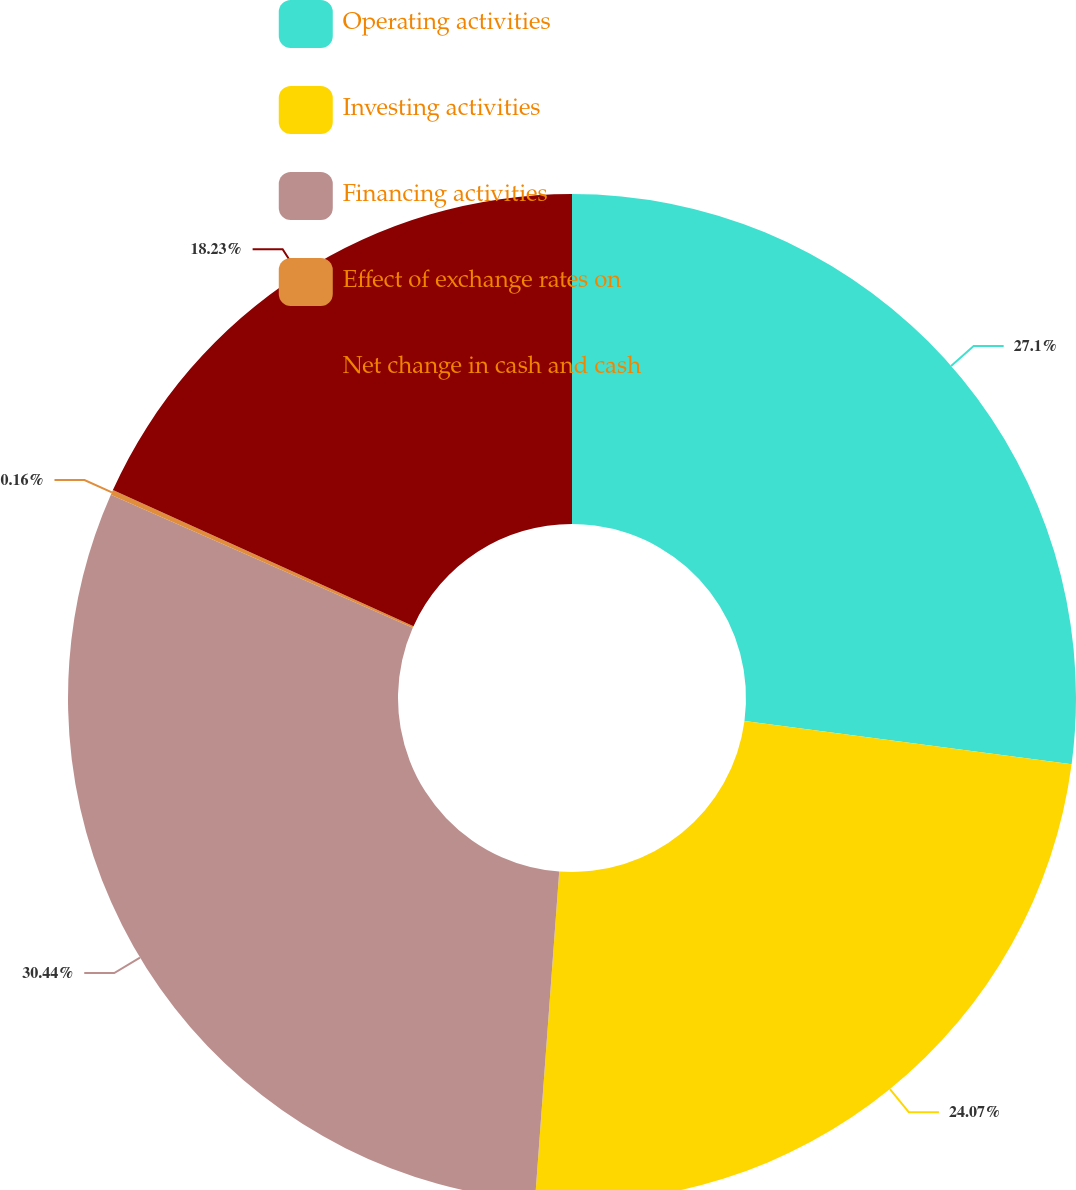Convert chart. <chart><loc_0><loc_0><loc_500><loc_500><pie_chart><fcel>Operating activities<fcel>Investing activities<fcel>Financing activities<fcel>Effect of exchange rates on<fcel>Net change in cash and cash<nl><fcel>27.1%<fcel>24.07%<fcel>30.44%<fcel>0.16%<fcel>18.23%<nl></chart> 